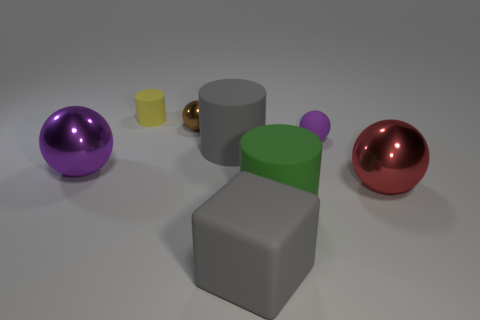Subtract all large red metallic balls. How many balls are left? 3 Add 2 large things. How many objects exist? 10 Subtract 2 purple balls. How many objects are left? 6 Subtract all cylinders. How many objects are left? 5 Subtract 1 balls. How many balls are left? 3 Subtract all brown spheres. Subtract all green blocks. How many spheres are left? 3 Subtract all green cylinders. How many purple balls are left? 2 Subtract all large brown rubber cubes. Subtract all green things. How many objects are left? 7 Add 8 green objects. How many green objects are left? 9 Add 3 cubes. How many cubes exist? 4 